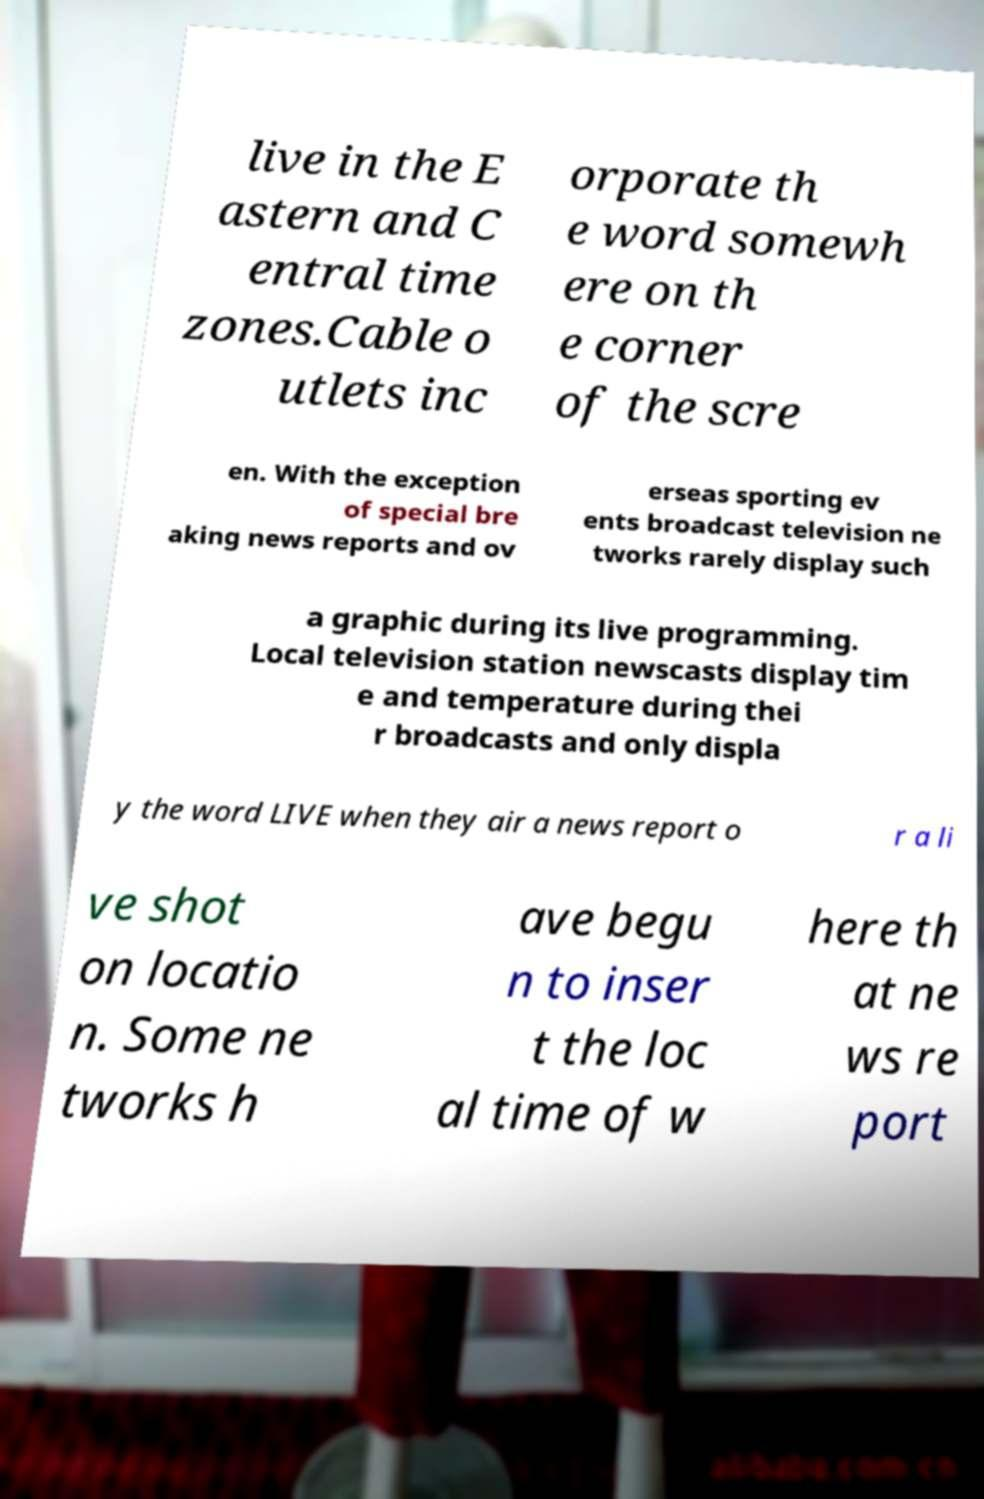Please identify and transcribe the text found in this image. live in the E astern and C entral time zones.Cable o utlets inc orporate th e word somewh ere on th e corner of the scre en. With the exception of special bre aking news reports and ov erseas sporting ev ents broadcast television ne tworks rarely display such a graphic during its live programming. Local television station newscasts display tim e and temperature during thei r broadcasts and only displa y the word LIVE when they air a news report o r a li ve shot on locatio n. Some ne tworks h ave begu n to inser t the loc al time of w here th at ne ws re port 